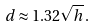Convert formula to latex. <formula><loc_0><loc_0><loc_500><loc_500>d \approx 1 . 3 2 { \sqrt { h } } \, .</formula> 